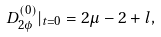<formula> <loc_0><loc_0><loc_500><loc_500>\ D ^ { ( 0 ) } _ { 2 \phi } | _ { t = 0 } = 2 \mu - 2 + l ,</formula> 